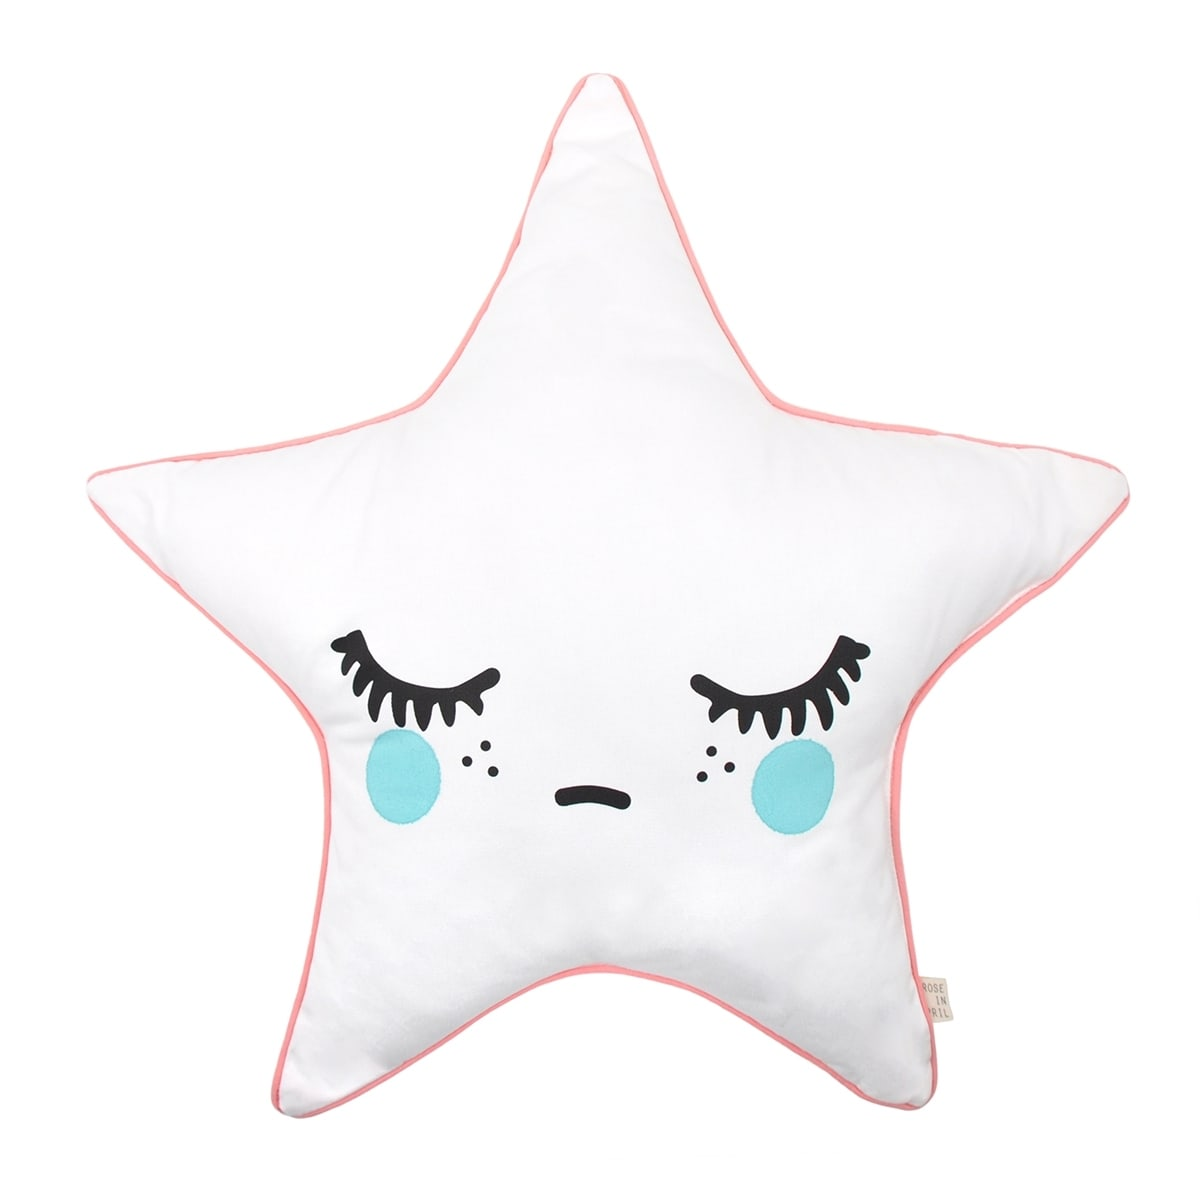What kind of stories or scenarios could a parent create using this pillow as a character in a storytelling session with their child? Using this star-shaped pillow as a character, a parent could craft imaginative bedtime stories. One scenario could involve the pillow being a magical star that comes to life at night to guide children on dreamy adventures through the night sky. It could take them visiting other friendly stars and planets, teaching them about constellations, and ensuring they return safely home by morning. Another story could involve the star pillow helping children solve nighttime mysteries or assisting other dreamland characters in need. The whimsical face and plush design make it an ideal protagonist for soothing, imaginative narratives that enhance bedtime routines. 